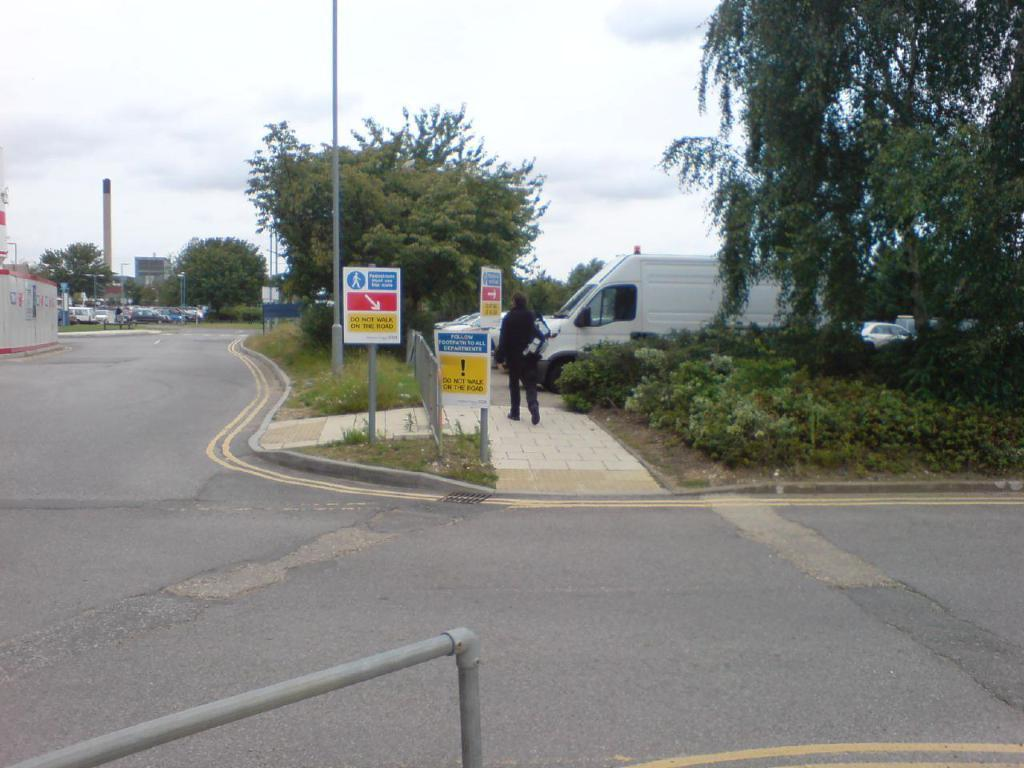What is the person in the image doing? There is a person walking in the image. What else can be seen in the image besides the person? There are vehicles, trees, poles, and boards in the image. What is the color of the sky in the image? The sky is white in color. What type of alarm can be heard going off in the image? There is no alarm present in the image, so it cannot be heard. 